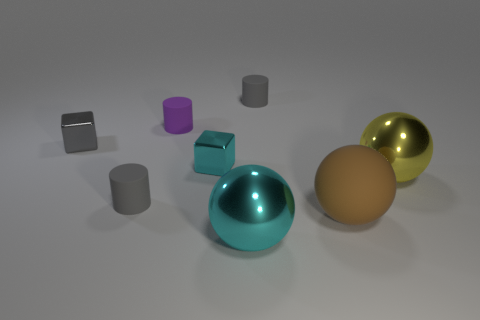Add 1 large brown balls. How many objects exist? 9 Subtract all cylinders. How many objects are left? 5 Add 3 large yellow objects. How many large yellow objects exist? 4 Subtract 0 brown cylinders. How many objects are left? 8 Subtract all big gray spheres. Subtract all shiny cubes. How many objects are left? 6 Add 5 gray matte things. How many gray matte things are left? 7 